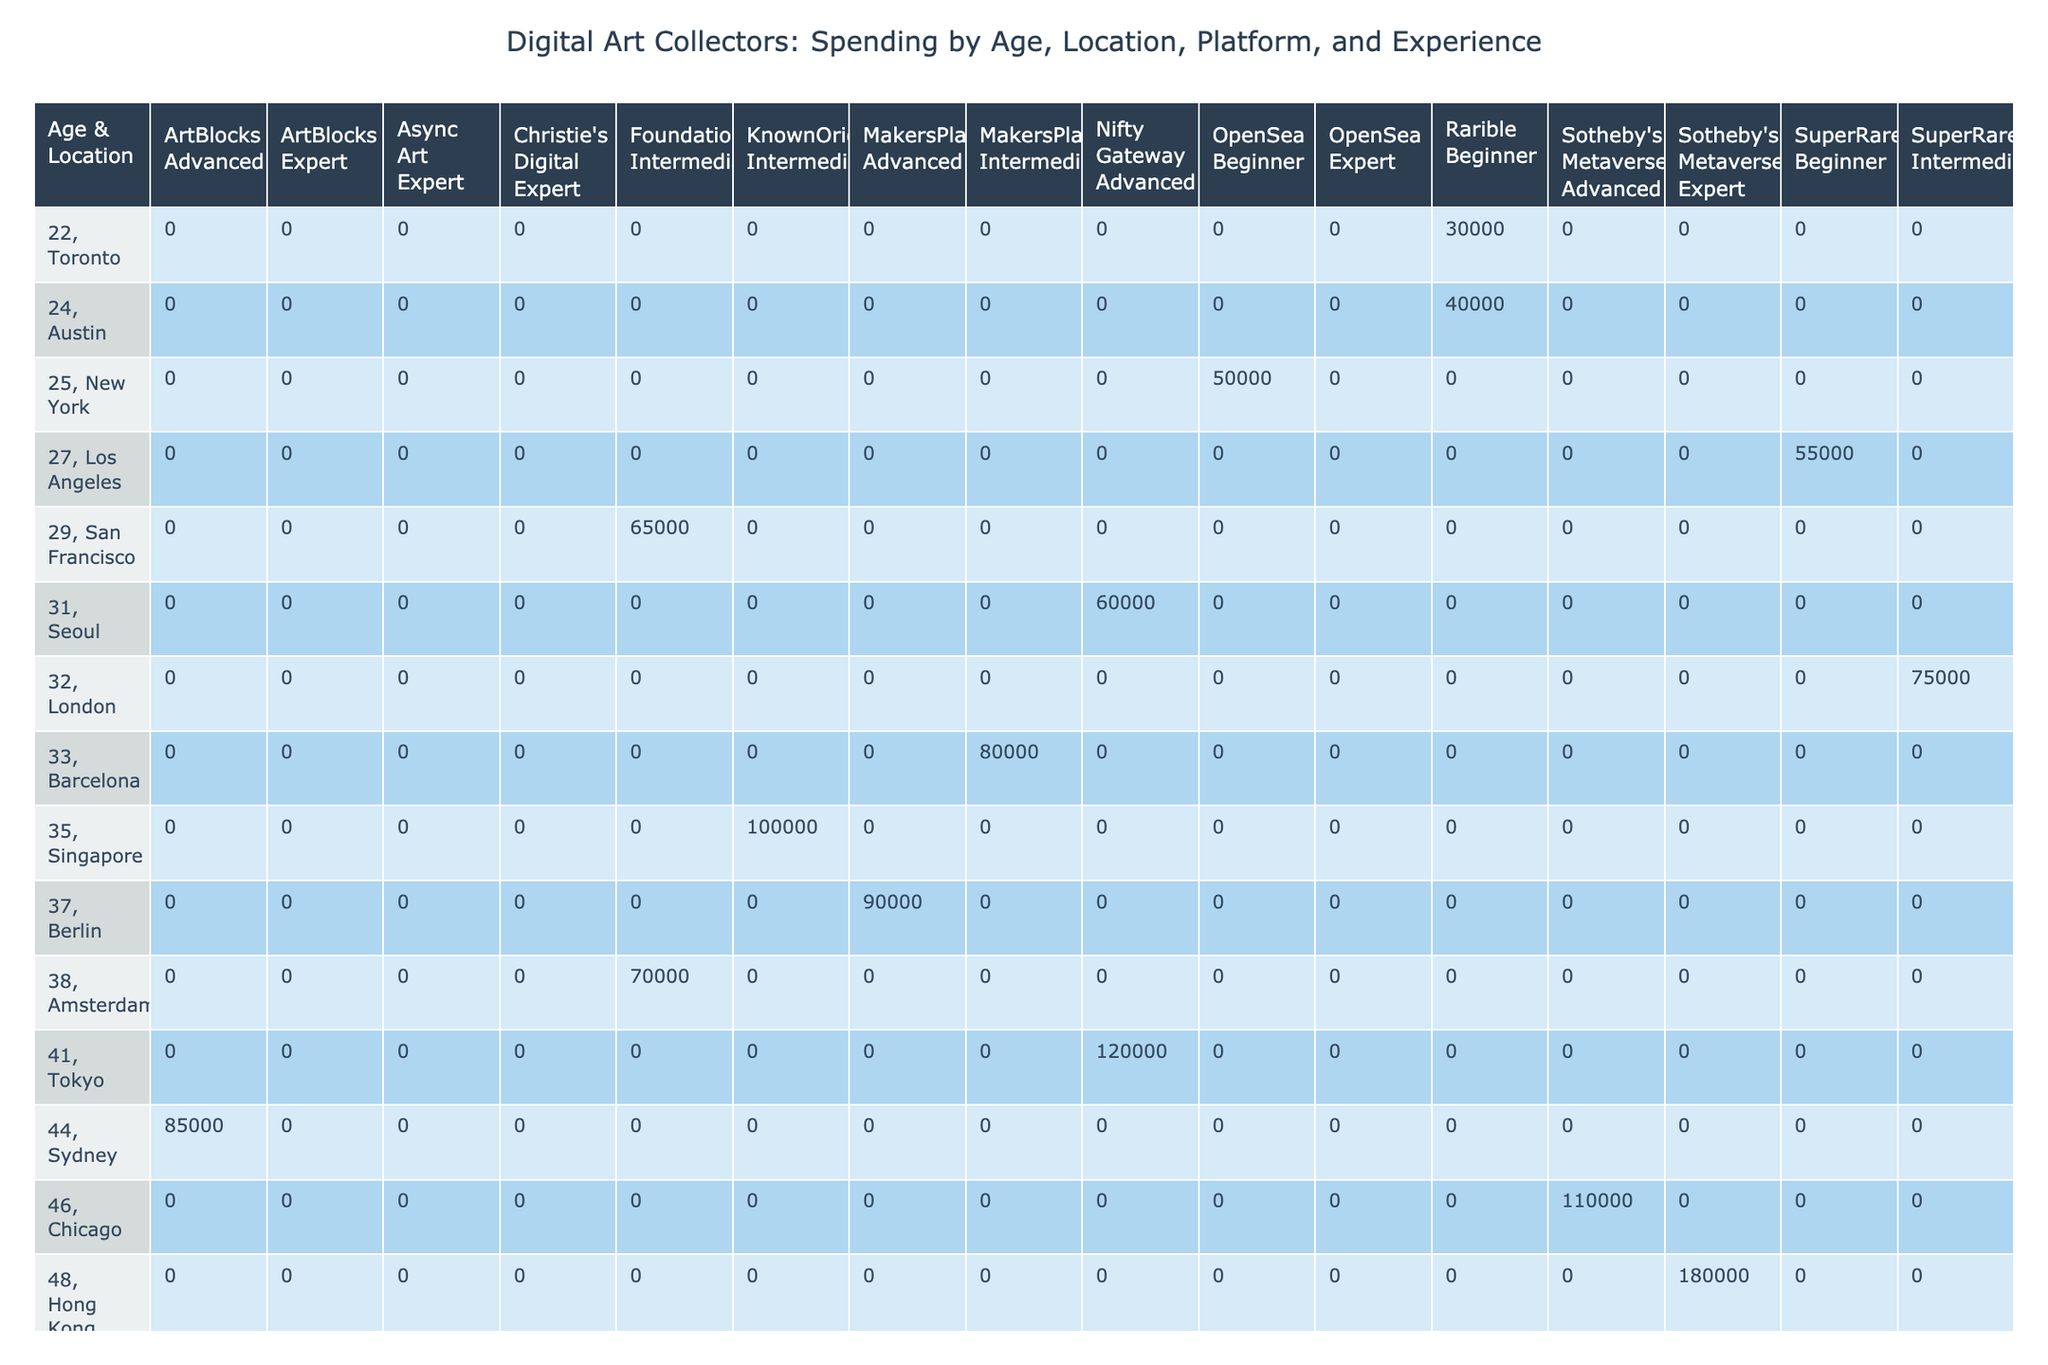What is the total annual spending of collectors in New York? In the table, the only entry for New York shows an annual spending of 50,000. Thus, the total annual spending for collectors in New York is simply 50,000.
Answer: 50,000 Which location has the highest average annual spending among collectors? By checking the average annual spending of each location based on the available data, Dubai stands out with a spending of 250,000. Therefore, Dubai has the highest average annual spending among collectors.
Answer: Dubai Is there a collector in Toronto with an advanced collecting experience? Reviewing the table, the Toronto collector with an annual spending of 30,000 is noted as a beginner. Therefore, no collectors in Toronto have advanced collecting experience.
Answer: No What is the average annual spending for beginner collectors? The table shows beginner collectors in New York (50,000), Toronto (30,000), and Los Angeles (55,000). The sum of these amounts is 135,000, and there are three collectors. Thus, the average is 135,000 divided by 3, which equals 45,000.
Answer: 45,000 How much more does the average annual spending of expert collectors compare to that of intermediate collectors? The expert collectors' annual spending includes 200,000 in Paris, 180,000 in Hong Kong, and 250,000 in Dubai, totaling 630,000 from three collectors, making an average of 210,000. The intermediate collectors' total spending adds up to 70,000 in London, 65,000 in San Francisco, 100,000 in Singapore, 70,000 in Amsterdam, and 80,000 in Barcelona, for a total of 385,000 from five collectors, giving an average of 77,000. Therefore, subtracting these averages results in 210,000 - 77,000 = 133,000.
Answer: 133,000 Are there any collectors over the age of 50 who prefer SuperRare? By scanning the table, collectors over 50 years of age include one (55, Paris) who prefers Christie's Digital and another (52, Miami) who prefers OpenSea, with no entries found for SuperRare among collectors aged over 50. Thus, it confirms that there are no such collectors.
Answer: No 